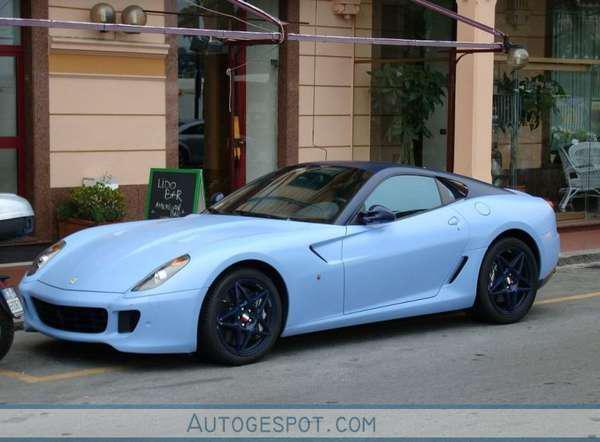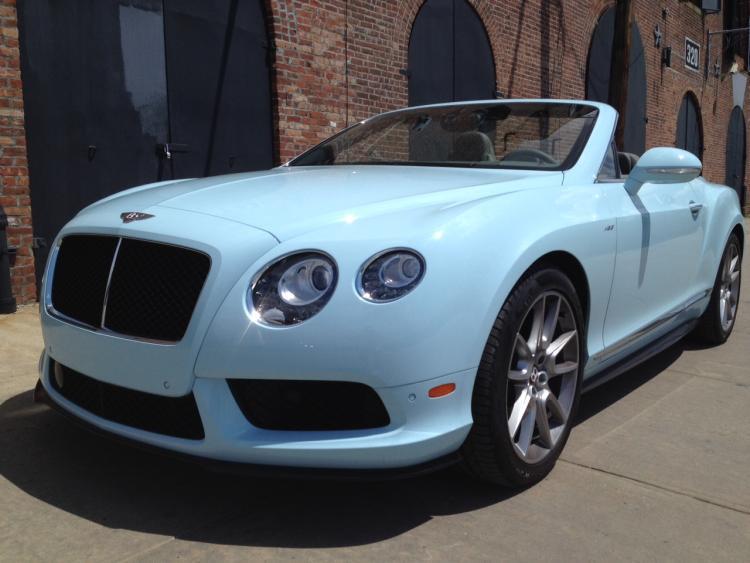The first image is the image on the left, the second image is the image on the right. Evaluate the accuracy of this statement regarding the images: "The left image shows a convertible car with the top up while the right image shows a convertible with the top down". Is it true? Answer yes or no. Yes. The first image is the image on the left, the second image is the image on the right. For the images shown, is this caption "The top is up on the image on the left." true? Answer yes or no. Yes. 